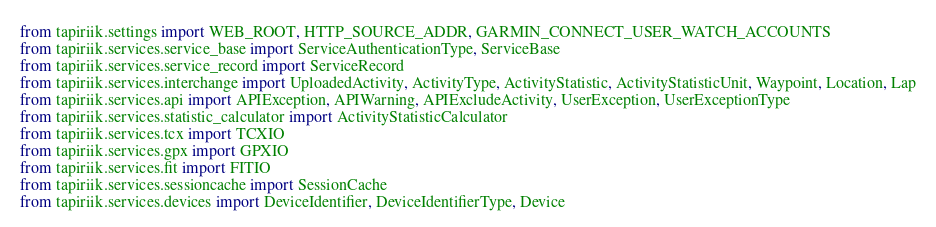<code> <loc_0><loc_0><loc_500><loc_500><_Python_>from tapiriik.settings import WEB_ROOT, HTTP_SOURCE_ADDR, GARMIN_CONNECT_USER_WATCH_ACCOUNTS
from tapiriik.services.service_base import ServiceAuthenticationType, ServiceBase
from tapiriik.services.service_record import ServiceRecord
from tapiriik.services.interchange import UploadedActivity, ActivityType, ActivityStatistic, ActivityStatisticUnit, Waypoint, Location, Lap
from tapiriik.services.api import APIException, APIWarning, APIExcludeActivity, UserException, UserExceptionType
from tapiriik.services.statistic_calculator import ActivityStatisticCalculator
from tapiriik.services.tcx import TCXIO
from tapiriik.services.gpx import GPXIO
from tapiriik.services.fit import FITIO
from tapiriik.services.sessioncache import SessionCache
from tapiriik.services.devices import DeviceIdentifier, DeviceIdentifierType, Device</code> 